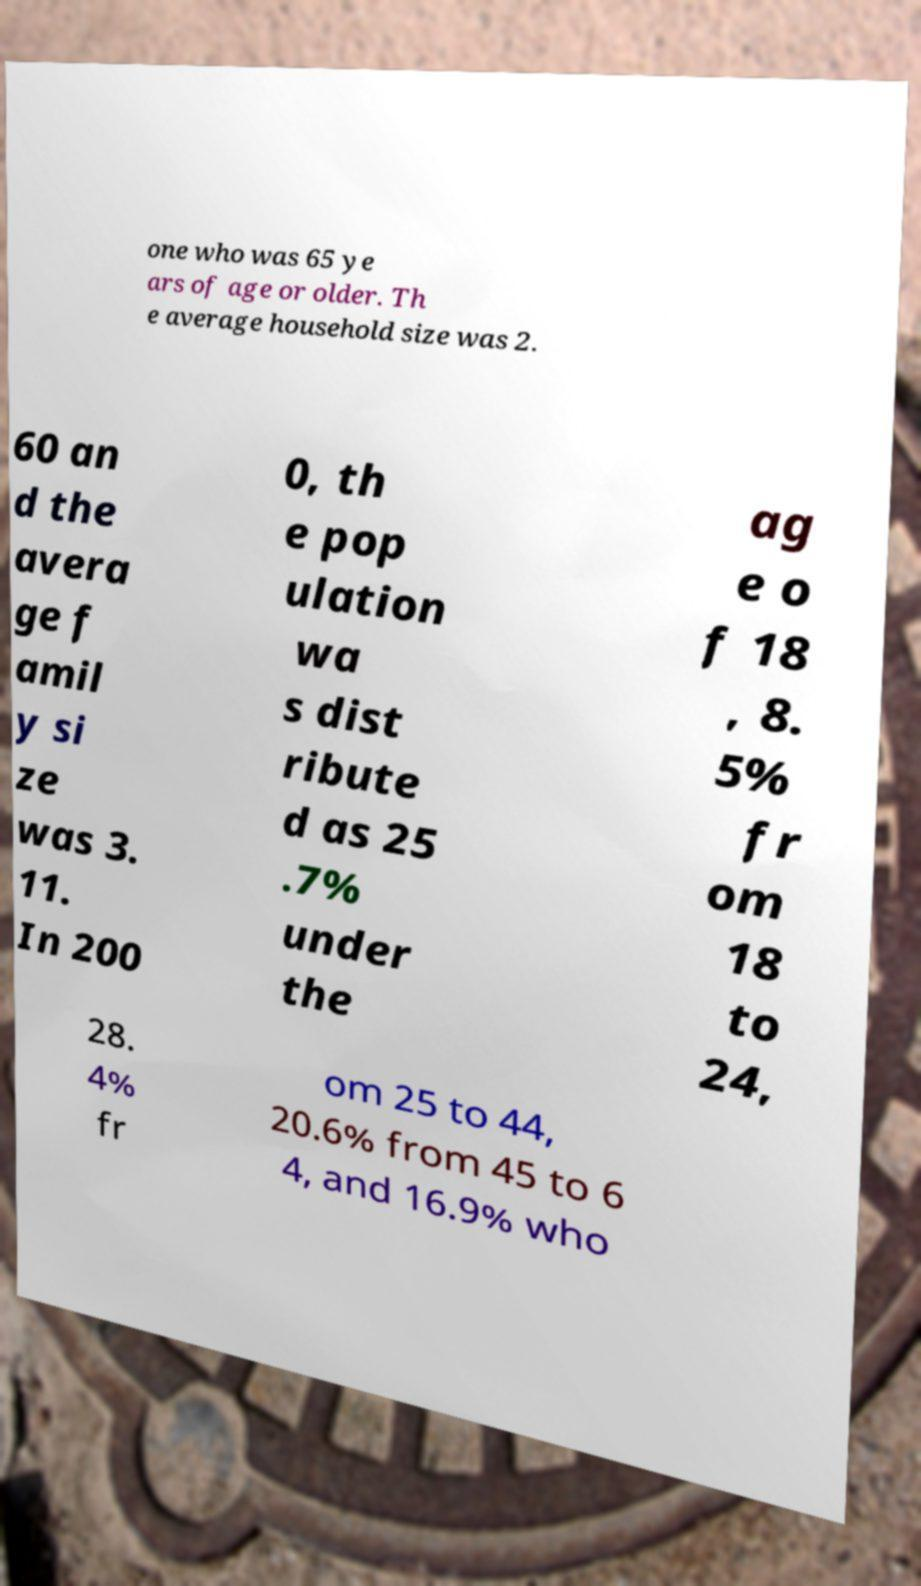Can you read and provide the text displayed in the image?This photo seems to have some interesting text. Can you extract and type it out for me? one who was 65 ye ars of age or older. Th e average household size was 2. 60 an d the avera ge f amil y si ze was 3. 11. In 200 0, th e pop ulation wa s dist ribute d as 25 .7% under the ag e o f 18 , 8. 5% fr om 18 to 24, 28. 4% fr om 25 to 44, 20.6% from 45 to 6 4, and 16.9% who 